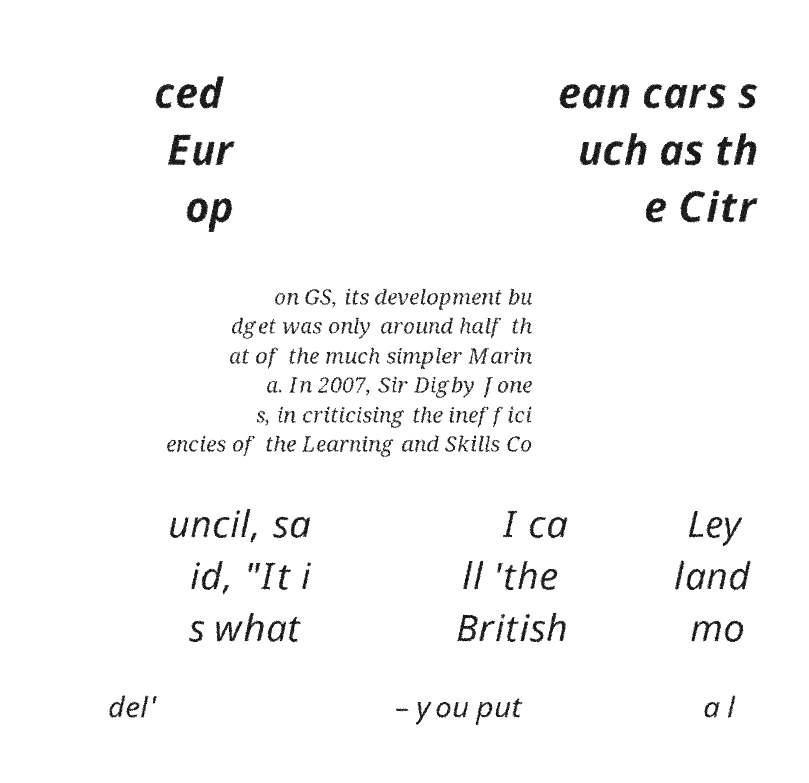Could you extract and type out the text from this image? ced Eur op ean cars s uch as th e Citr on GS, its development bu dget was only around half th at of the much simpler Marin a. In 2007, Sir Digby Jone s, in criticising the ineffici encies of the Learning and Skills Co uncil, sa id, "It i s what I ca ll 'the British Ley land mo del' – you put a l 